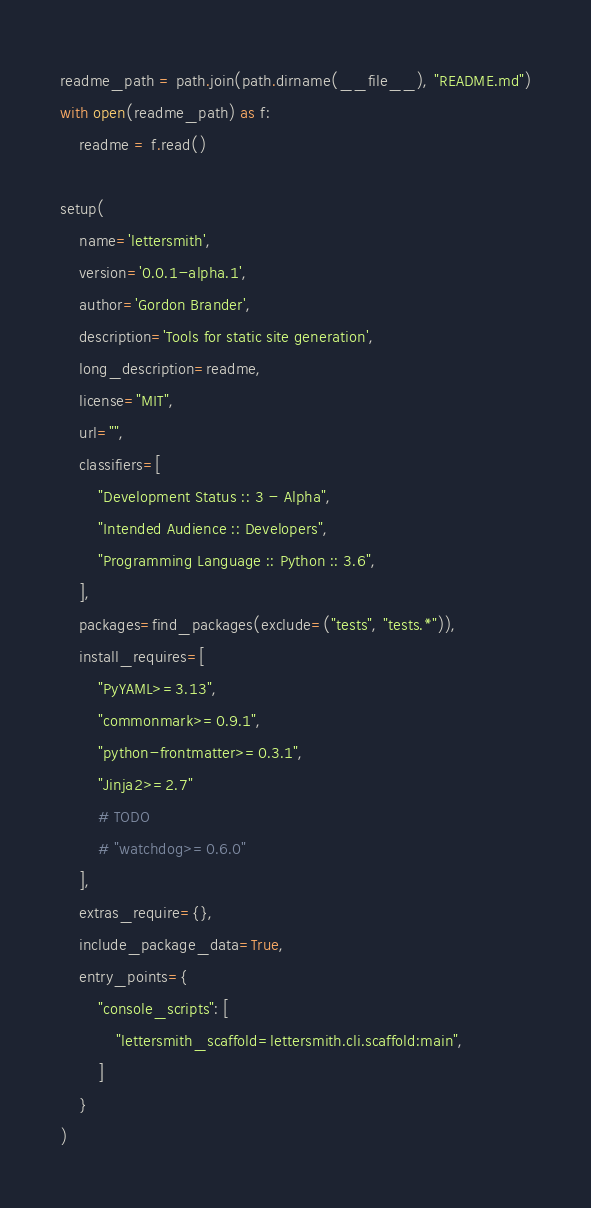Convert code to text. <code><loc_0><loc_0><loc_500><loc_500><_Python_>readme_path = path.join(path.dirname(__file__), "README.md")
with open(readme_path) as f:
    readme = f.read()

setup(
    name='lettersmith',
    version='0.0.1-alpha.1',
    author='Gordon Brander',
    description='Tools for static site generation',
    long_description=readme,
    license="MIT",
    url="",
    classifiers=[
        "Development Status :: 3 - Alpha",
        "Intended Audience :: Developers",
        "Programming Language :: Python :: 3.6",
    ],
    packages=find_packages(exclude=("tests", "tests.*")),
    install_requires=[
        "PyYAML>=3.13",
        "commonmark>=0.9.1",
        "python-frontmatter>=0.3.1",
        "Jinja2>=2.7"
        # TODO
        # "watchdog>=0.6.0"
    ],
    extras_require={},
    include_package_data=True,
    entry_points={
        "console_scripts": [
            "lettersmith_scaffold=lettersmith.cli.scaffold:main",
        ]
    }
)
</code> 